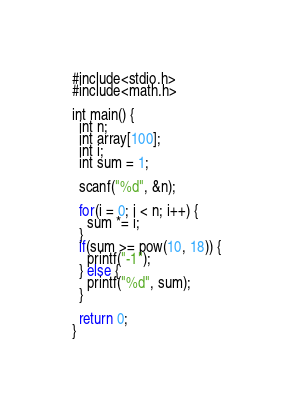<code> <loc_0><loc_0><loc_500><loc_500><_Swift_>#include<stdio.h>
#include<math.h>

int main() {
  int n;
  int array[100];
  int i;
  int sum = 1;
  
  scanf("%d", &n);
  
  for(i = 0; i < n; i++) {
    sum *= i;
  }
  if(sum >= pow(10, 18)) {
    printf("-1");
  } else {
    printf("%d", sum);
  }
  
  return 0;
}</code> 